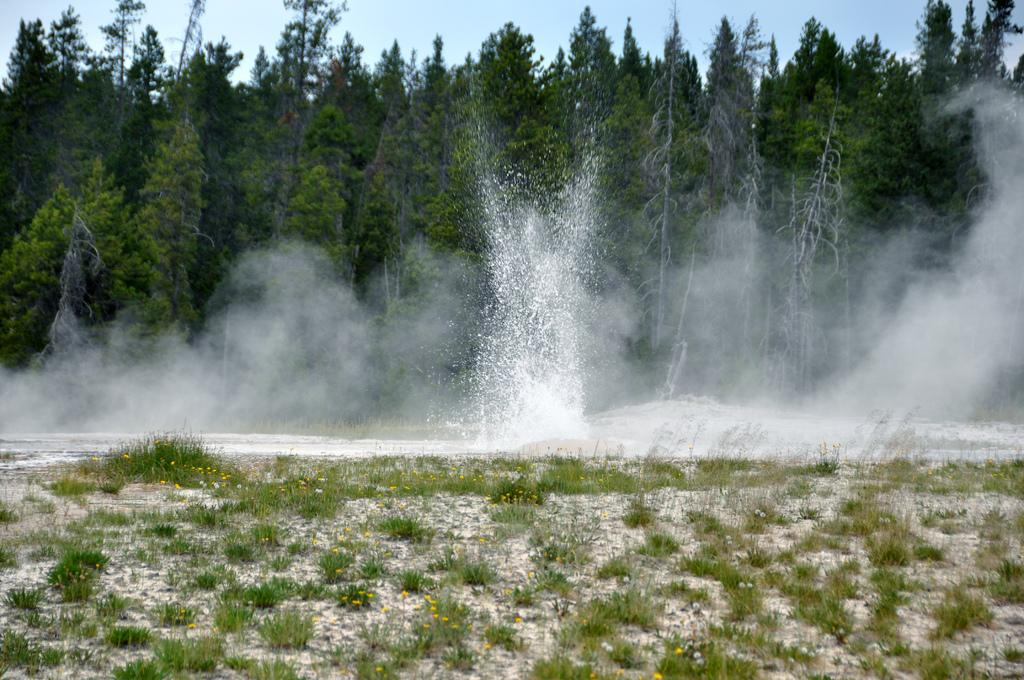What type of surface is on the ground in the image? There is grass on the ground in the image. What can be seen in the distance in the image? There is water, smoke, trees, and the sky visible in the background of the image. What type of fruit is being judged in a circle in the image? There is no fruit or judging activity present in the image. 